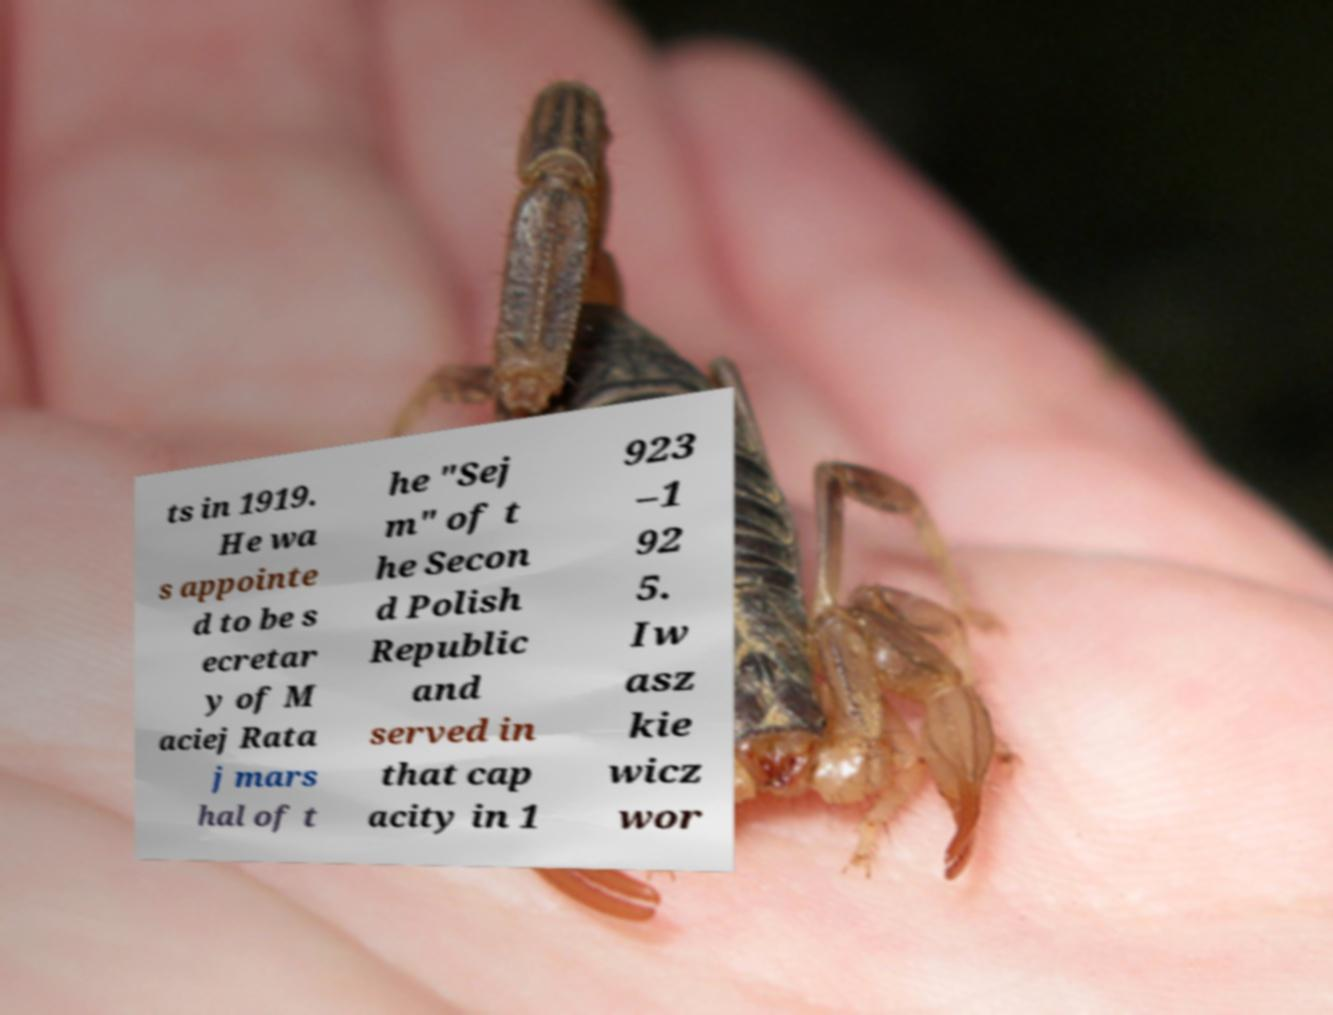Could you assist in decoding the text presented in this image and type it out clearly? ts in 1919. He wa s appointe d to be s ecretar y of M aciej Rata j mars hal of t he "Sej m" of t he Secon d Polish Republic and served in that cap acity in 1 923 –1 92 5. Iw asz kie wicz wor 